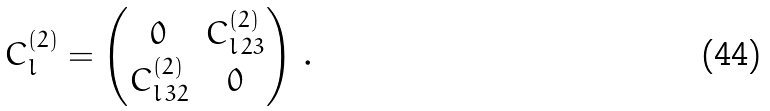<formula> <loc_0><loc_0><loc_500><loc_500>C ^ { ( 2 ) } _ { l } = \begin{pmatrix} 0 & C ^ { ( 2 ) } _ { l \, 2 3 } \\ C ^ { ( 2 ) } _ { l \, 3 2 } & 0 \end{pmatrix} \, .</formula> 